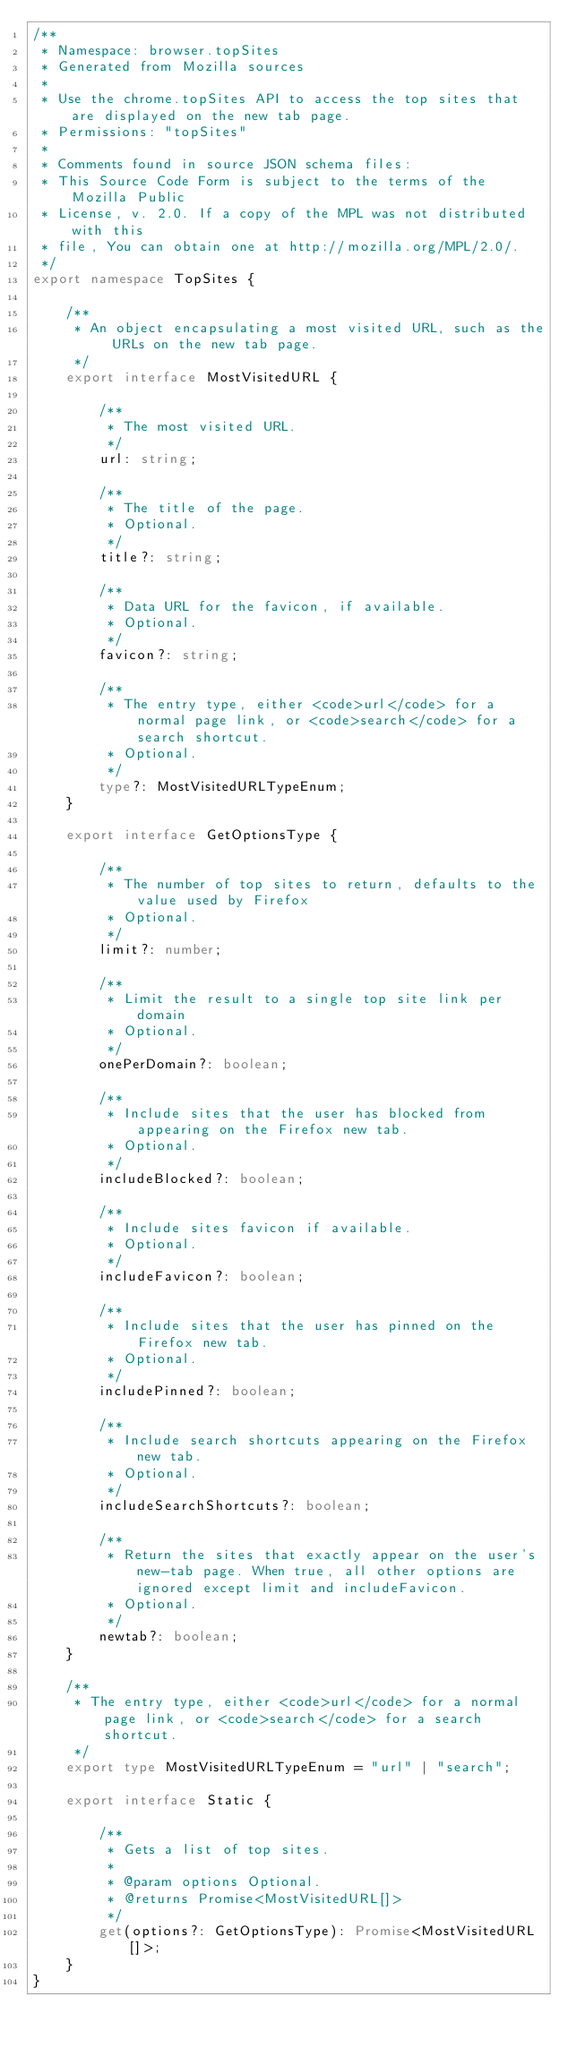Convert code to text. <code><loc_0><loc_0><loc_500><loc_500><_TypeScript_>/**
 * Namespace: browser.topSites
 * Generated from Mozilla sources
 *
 * Use the chrome.topSites API to access the top sites that are displayed on the new tab page. 
 * Permissions: "topSites"
 *
 * Comments found in source JSON schema files:
 * This Source Code Form is subject to the terms of the Mozilla Public
 * License, v. 2.0. If a copy of the MPL was not distributed with this
 * file, You can obtain one at http://mozilla.org/MPL/2.0/.
 */
export namespace TopSites {

    /**
     * An object encapsulating a most visited URL, such as the URLs on the new tab page.
     */
    export interface MostVisitedURL {

        /**
         * The most visited URL.
         */
        url: string;

        /**
         * The title of the page.
         * Optional.
         */
        title?: string;

        /**
         * Data URL for the favicon, if available.
         * Optional.
         */
        favicon?: string;

        /**
         * The entry type, either <code>url</code> for a normal page link, or <code>search</code> for a search shortcut.
         * Optional.
         */
        type?: MostVisitedURLTypeEnum;
    }

    export interface GetOptionsType {

        /**
         * The number of top sites to return, defaults to the value used by Firefox
         * Optional.
         */
        limit?: number;

        /**
         * Limit the result to a single top site link per domain
         * Optional.
         */
        onePerDomain?: boolean;

        /**
         * Include sites that the user has blocked from appearing on the Firefox new tab.
         * Optional.
         */
        includeBlocked?: boolean;

        /**
         * Include sites favicon if available.
         * Optional.
         */
        includeFavicon?: boolean;

        /**
         * Include sites that the user has pinned on the Firefox new tab.
         * Optional.
         */
        includePinned?: boolean;

        /**
         * Include search shortcuts appearing on the Firefox new tab.
         * Optional.
         */
        includeSearchShortcuts?: boolean;

        /**
         * Return the sites that exactly appear on the user's new-tab page. When true, all other options are ignored except limit and includeFavicon.
         * Optional.
         */
        newtab?: boolean;
    }

    /**
     * The entry type, either <code>url</code> for a normal page link, or <code>search</code> for a search shortcut.
     */
    export type MostVisitedURLTypeEnum = "url" | "search";

    export interface Static {

        /**
         * Gets a list of top sites.
         *
         * @param options Optional.
         * @returns Promise<MostVisitedURL[]>
         */
        get(options?: GetOptionsType): Promise<MostVisitedURL[]>;
    }
}
</code> 